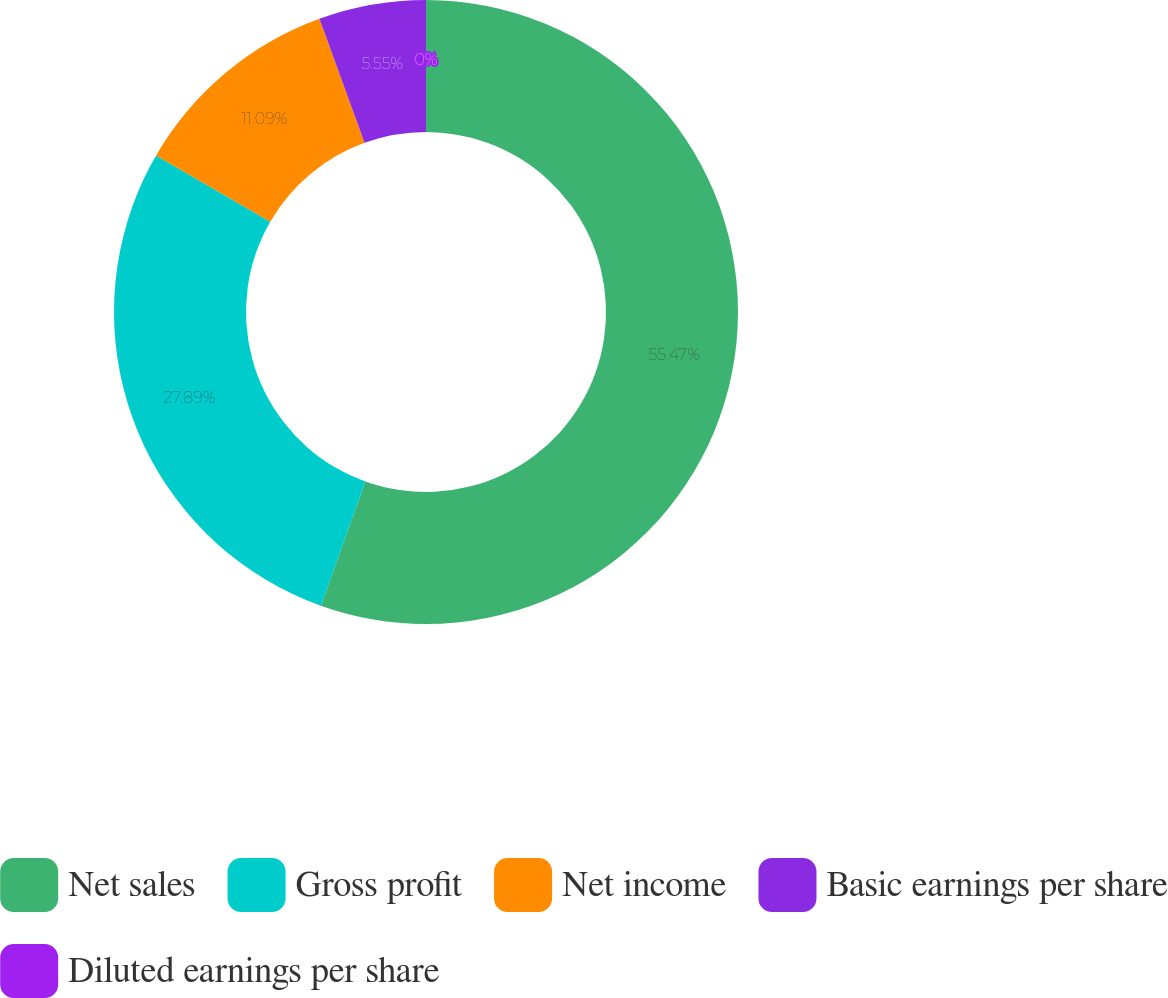<chart> <loc_0><loc_0><loc_500><loc_500><pie_chart><fcel>Net sales<fcel>Gross profit<fcel>Net income<fcel>Basic earnings per share<fcel>Diluted earnings per share<nl><fcel>55.47%<fcel>27.89%<fcel>11.09%<fcel>5.55%<fcel>0.0%<nl></chart> 